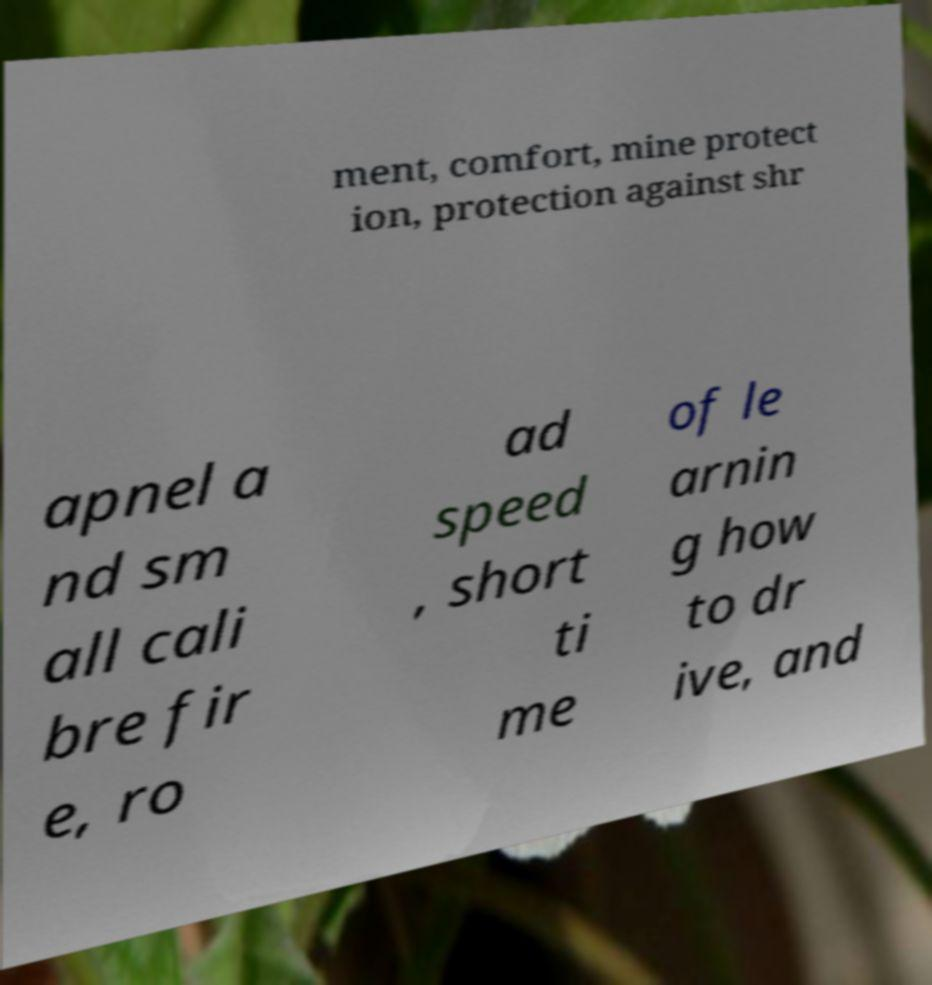Could you assist in decoding the text presented in this image and type it out clearly? ment, comfort, mine protect ion, protection against shr apnel a nd sm all cali bre fir e, ro ad speed , short ti me of le arnin g how to dr ive, and 